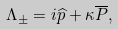Convert formula to latex. <formula><loc_0><loc_0><loc_500><loc_500>\Lambda _ { \pm } = i \widehat { p } + \kappa \overline { P } ,</formula> 